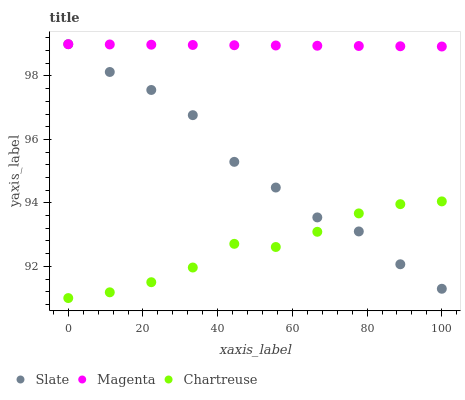Does Chartreuse have the minimum area under the curve?
Answer yes or no. Yes. Does Magenta have the maximum area under the curve?
Answer yes or no. Yes. Does Magenta have the minimum area under the curve?
Answer yes or no. No. Does Chartreuse have the maximum area under the curve?
Answer yes or no. No. Is Magenta the smoothest?
Answer yes or no. Yes. Is Slate the roughest?
Answer yes or no. Yes. Is Chartreuse the smoothest?
Answer yes or no. No. Is Chartreuse the roughest?
Answer yes or no. No. Does Chartreuse have the lowest value?
Answer yes or no. Yes. Does Magenta have the lowest value?
Answer yes or no. No. Does Magenta have the highest value?
Answer yes or no. Yes. Does Chartreuse have the highest value?
Answer yes or no. No. Is Chartreuse less than Magenta?
Answer yes or no. Yes. Is Magenta greater than Chartreuse?
Answer yes or no. Yes. Does Slate intersect Magenta?
Answer yes or no. Yes. Is Slate less than Magenta?
Answer yes or no. No. Is Slate greater than Magenta?
Answer yes or no. No. Does Chartreuse intersect Magenta?
Answer yes or no. No. 